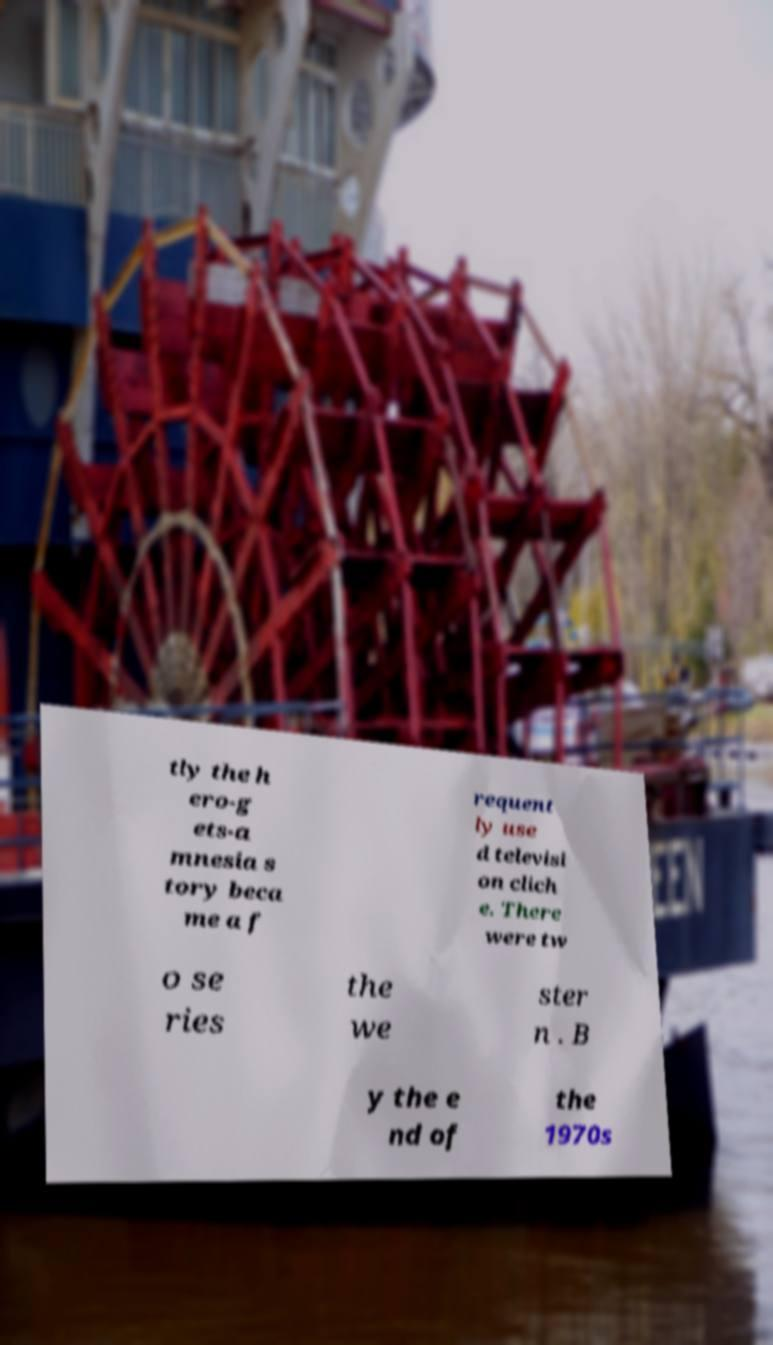For documentation purposes, I need the text within this image transcribed. Could you provide that? tly the h ero-g ets-a mnesia s tory beca me a f requent ly use d televisi on clich e. There were tw o se ries the we ster n . B y the e nd of the 1970s 